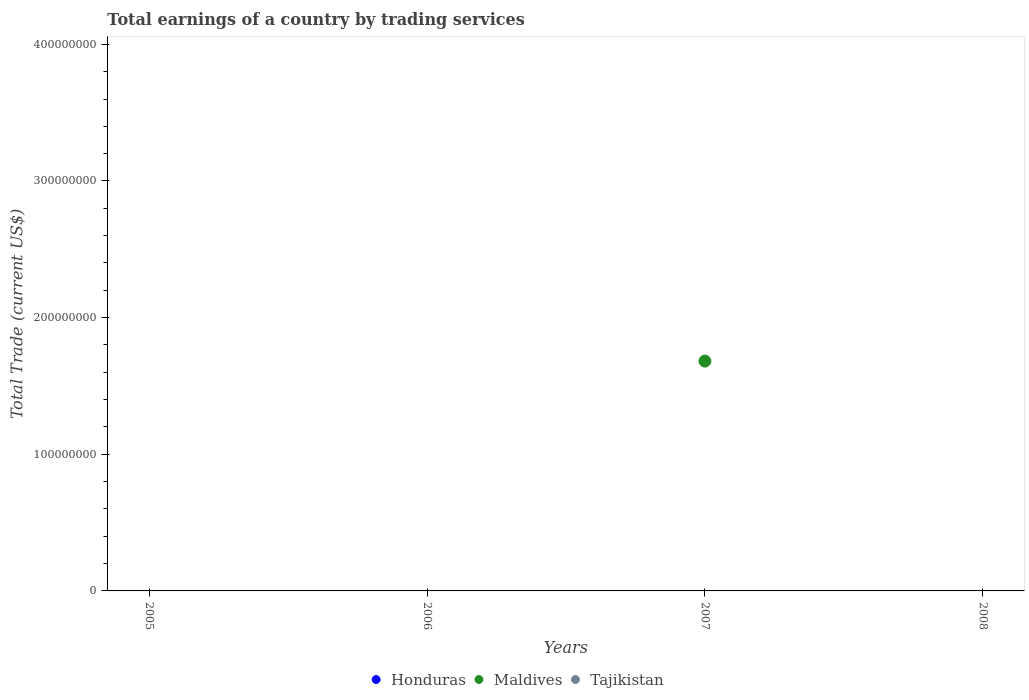How many different coloured dotlines are there?
Offer a very short reply. 1. Is the number of dotlines equal to the number of legend labels?
Your answer should be very brief. No. Across all years, what is the minimum total earnings in Maldives?
Offer a terse response. 0. In which year was the total earnings in Maldives maximum?
Your answer should be very brief. 2007. What is the total total earnings in Maldives in the graph?
Offer a terse response. 1.68e+08. What is the difference between the total earnings in Tajikistan in 2005 and the total earnings in Honduras in 2007?
Your answer should be compact. 0. What is the average total earnings in Honduras per year?
Provide a short and direct response. 0. What is the difference between the highest and the lowest total earnings in Maldives?
Make the answer very short. 1.68e+08. In how many years, is the total earnings in Tajikistan greater than the average total earnings in Tajikistan taken over all years?
Your response must be concise. 0. Does the total earnings in Maldives monotonically increase over the years?
Make the answer very short. No. How many dotlines are there?
Provide a succinct answer. 1. What is the difference between two consecutive major ticks on the Y-axis?
Make the answer very short. 1.00e+08. Does the graph contain grids?
Give a very brief answer. No. Where does the legend appear in the graph?
Ensure brevity in your answer.  Bottom center. What is the title of the graph?
Your response must be concise. Total earnings of a country by trading services. Does "Philippines" appear as one of the legend labels in the graph?
Make the answer very short. No. What is the label or title of the Y-axis?
Provide a succinct answer. Total Trade (current US$). What is the Total Trade (current US$) in Honduras in 2005?
Ensure brevity in your answer.  0. What is the Total Trade (current US$) in Honduras in 2006?
Provide a succinct answer. 0. What is the Total Trade (current US$) of Maldives in 2006?
Provide a short and direct response. 0. What is the Total Trade (current US$) of Honduras in 2007?
Your answer should be very brief. 0. What is the Total Trade (current US$) in Maldives in 2007?
Offer a terse response. 1.68e+08. What is the Total Trade (current US$) of Honduras in 2008?
Give a very brief answer. 0. What is the Total Trade (current US$) in Tajikistan in 2008?
Provide a succinct answer. 0. Across all years, what is the maximum Total Trade (current US$) of Maldives?
Your answer should be compact. 1.68e+08. Across all years, what is the minimum Total Trade (current US$) in Maldives?
Ensure brevity in your answer.  0. What is the total Total Trade (current US$) in Honduras in the graph?
Offer a terse response. 0. What is the total Total Trade (current US$) in Maldives in the graph?
Your response must be concise. 1.68e+08. What is the average Total Trade (current US$) in Maldives per year?
Give a very brief answer. 4.20e+07. What is the difference between the highest and the lowest Total Trade (current US$) of Maldives?
Provide a short and direct response. 1.68e+08. 